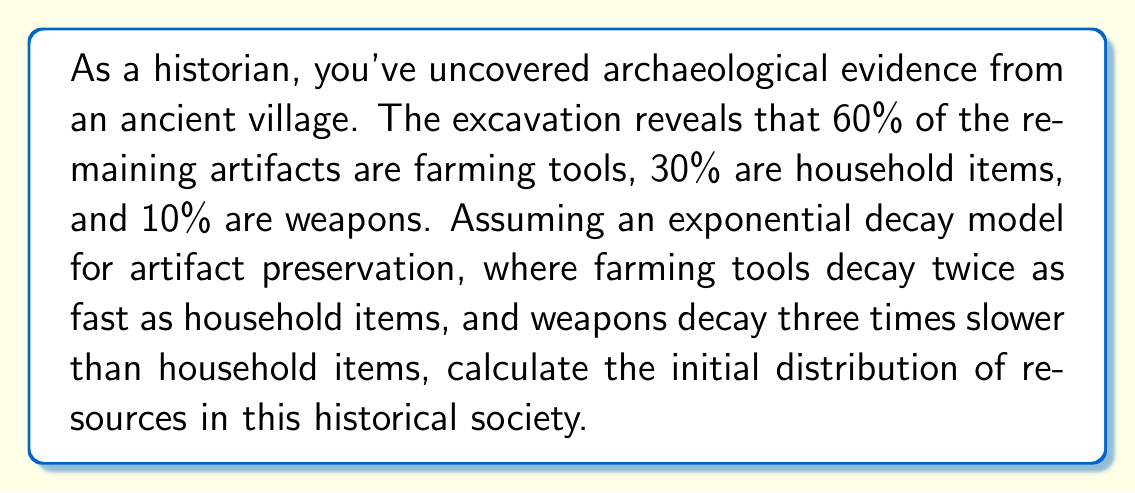Solve this math problem. Let's approach this step-by-step:

1) Let's define our variables:
   $x$ = initial percentage of farming tools
   $y$ = initial percentage of household items
   $z$ = initial percentage of weapons

2) We know that $x + y + z = 100\%$ (total resources)

3) Given the decay rates, we can set up equations based on the current percentages:
   $\frac{x}{e^{2k}} = 60\%$
   $\frac{y}{e^k} = 30\%$
   $\frac{z}{e^{k/3}} = 10\%$

   Where $k$ is some constant representing the decay rate of household items.

4) We can eliminate $k$ by taking ratios:
   $\frac{x}{y} = \frac{60}{30} \cdot e^k = 2e^k$
   $\frac{z}{y} = \frac{10}{30} \cdot e^{-2k/3} = \frac{1}{3}e^{-2k/3}$

5) From the first ratio:
   $x = 2ye^k$

6) From the second ratio:
   $z = \frac{1}{3}ye^{-2k/3}$

7) Substituting these into our total resources equation:
   $2ye^k + y + \frac{1}{3}ye^{-2k/3} = 100$

8) Dividing everything by $y$:
   $2e^k + 1 + \frac{1}{3}e^{-2k/3} = \frac{100}{y}$

9) The left side of this equation must equal a constant. The only way this is possible for all values of $k$ is if $e^k = 1$, which means $k = 0$.

10) Therefore, $x = 2y$ and $z = \frac{1}{3}y$

11) Substituting back into our total resources equation:
    $2y + y + \frac{1}{3}y = 100$
    $\frac{10}{3}y = 100$
    $y = 30$

12) Therefore:
    $x = 60$
    $y = 30$
    $z = 10$
Answer: 60% farming tools, 30% household items, 10% weapons 